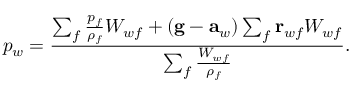<formula> <loc_0><loc_0><loc_500><loc_500>p _ { w } = \frac { \sum _ { f } \frac { p _ { f } } { \rho _ { f } } W _ { w f } + ( g - a _ { w } ) \sum _ { f } r _ { w f } W _ { w f } } { \sum _ { f } \frac { W _ { w f } } { \rho _ { f } } } .</formula> 